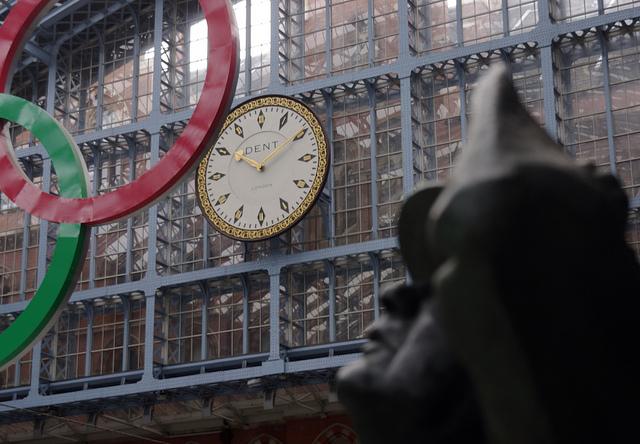What color are the rings?
Keep it brief. Green and red. Are the rings part of the Olympics symbol?
Answer briefly. Yes. What does the clock say?
Short answer required. 10:10. 